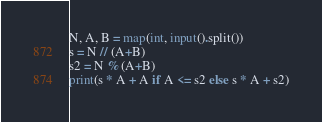<code> <loc_0><loc_0><loc_500><loc_500><_Python_>N, A, B = map(int, input().split())
s = N // (A+B)
s2 = N % (A+B)
print(s * A + A if A <= s2 else s * A + s2)</code> 